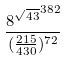<formula> <loc_0><loc_0><loc_500><loc_500>\frac { { 8 ^ { \sqrt { 4 3 } } } ^ { 3 8 2 } } { ( \frac { 2 1 5 } { 4 3 0 } ) ^ { 7 2 } }</formula> 